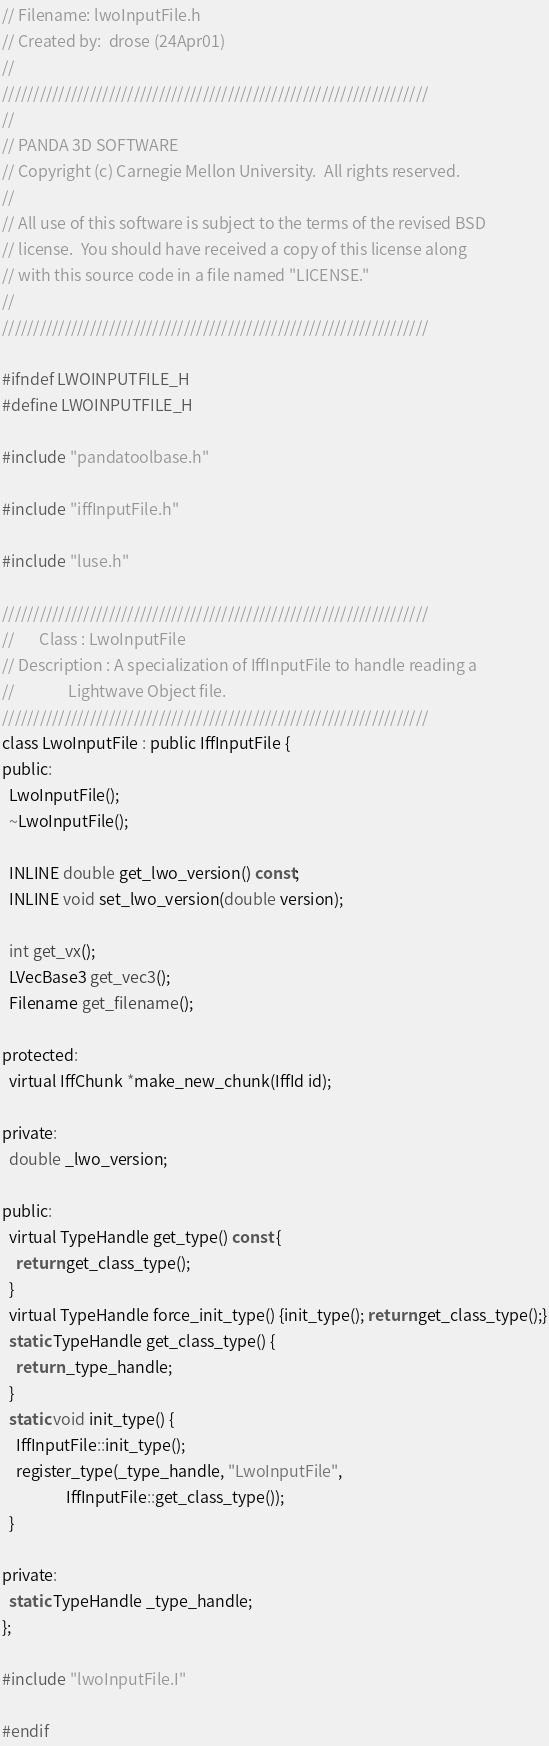<code> <loc_0><loc_0><loc_500><loc_500><_C_>// Filename: lwoInputFile.h
// Created by:  drose (24Apr01)
//
////////////////////////////////////////////////////////////////////
//
// PANDA 3D SOFTWARE
// Copyright (c) Carnegie Mellon University.  All rights reserved.
//
// All use of this software is subject to the terms of the revised BSD
// license.  You should have received a copy of this license along
// with this source code in a file named "LICENSE."
//
////////////////////////////////////////////////////////////////////

#ifndef LWOINPUTFILE_H
#define LWOINPUTFILE_H

#include "pandatoolbase.h"

#include "iffInputFile.h"

#include "luse.h"

////////////////////////////////////////////////////////////////////
//       Class : LwoInputFile
// Description : A specialization of IffInputFile to handle reading a
//               Lightwave Object file.
////////////////////////////////////////////////////////////////////
class LwoInputFile : public IffInputFile {
public:
  LwoInputFile();
  ~LwoInputFile();

  INLINE double get_lwo_version() const;
  INLINE void set_lwo_version(double version);

  int get_vx();
  LVecBase3 get_vec3();
  Filename get_filename();

protected:
  virtual IffChunk *make_new_chunk(IffId id);

private:
  double _lwo_version;

public:
  virtual TypeHandle get_type() const {
    return get_class_type();
  }
  virtual TypeHandle force_init_type() {init_type(); return get_class_type();}
  static TypeHandle get_class_type() {
    return _type_handle;
  }
  static void init_type() {
    IffInputFile::init_type();
    register_type(_type_handle, "LwoInputFile",
                  IffInputFile::get_class_type());
  }

private:
  static TypeHandle _type_handle;
};

#include "lwoInputFile.I"

#endif


</code> 